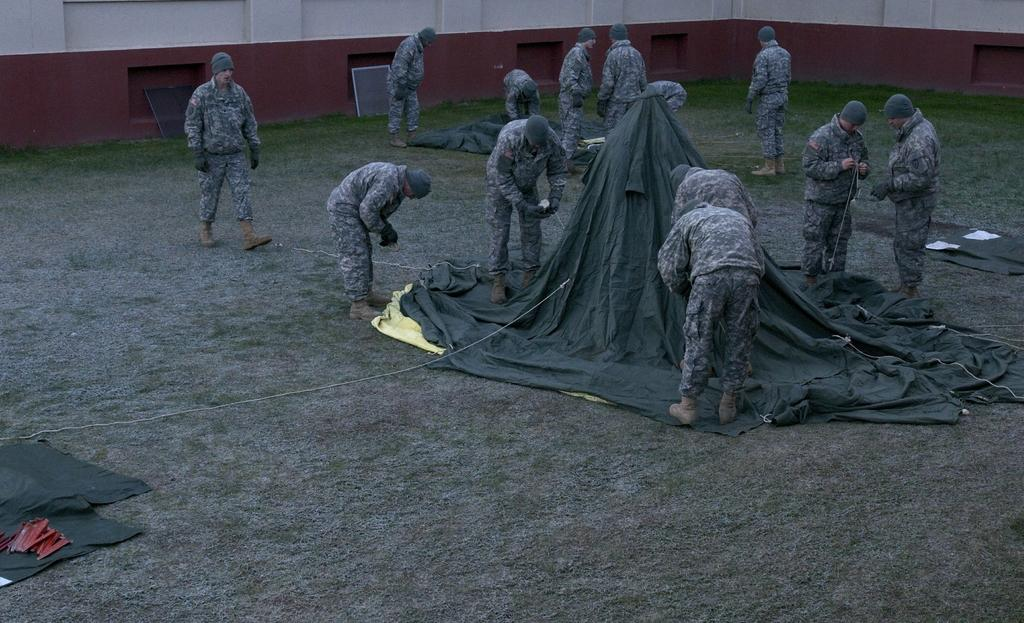What is the main focus of the image? The main focus of the image is the many persons in the center of the image. What structure can be seen in the image? There is a tent in the image. What type of terrain is visible at the bottom of the image? There is grass visible at the bottom of the image. What can be seen in the background of the image? There is a wall in the background of the image. What caption is written on the hat of the person in the image? There is no hat visible in the image, so there is no caption to be read. How many trains can be seen passing by in the image? There are no trains present in the image. 